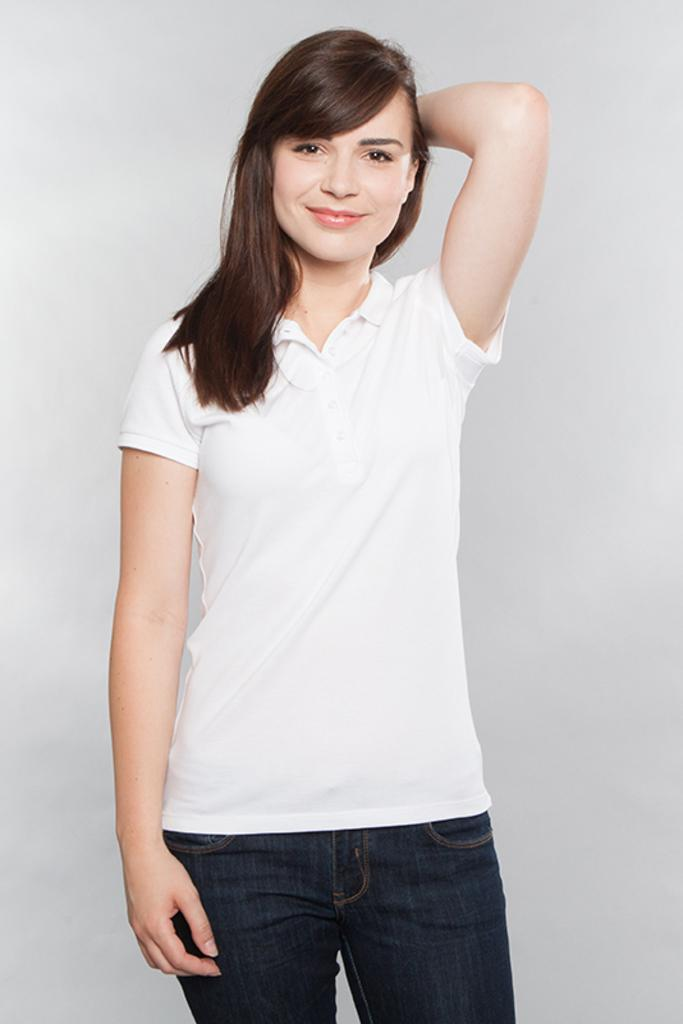What is the main subject of the image? There is a woman standing in the image. Can you describe the background of the image? The background of the image is plain. What type of cheese is the woman holding in the image? There is no cheese present in the image; the woman is not holding anything. 